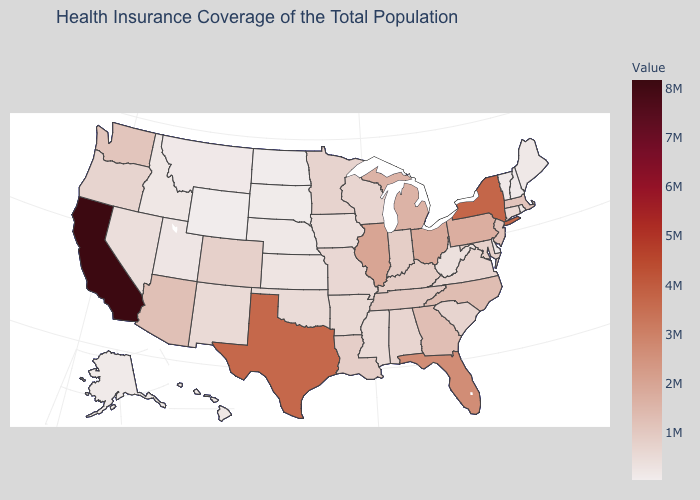Does the map have missing data?
Answer briefly. No. Does Connecticut have a lower value than Pennsylvania?
Write a very short answer. Yes. Which states have the highest value in the USA?
Quick response, please. California. 